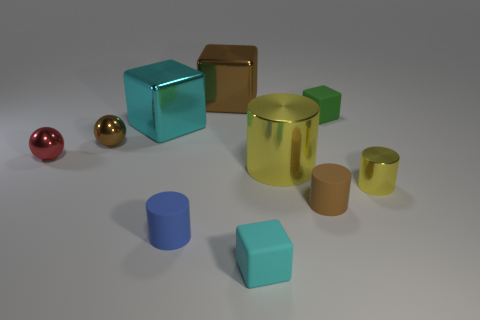Subtract all spheres. How many objects are left? 8 Add 7 large red metal spheres. How many large red metal spheres exist? 7 Subtract 0 cyan balls. How many objects are left? 10 Subtract all blue matte things. Subtract all shiny blocks. How many objects are left? 7 Add 6 cyan metal cubes. How many cyan metal cubes are left? 7 